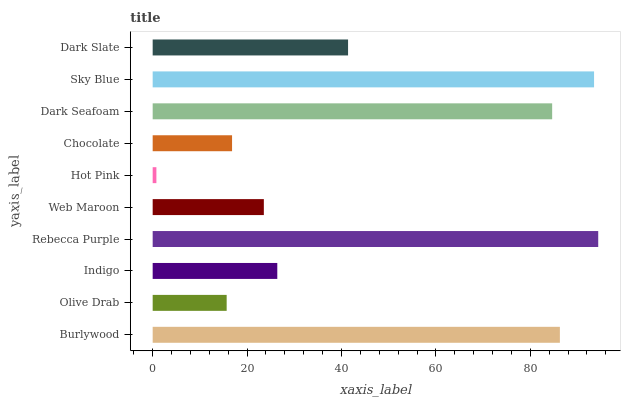Is Hot Pink the minimum?
Answer yes or no. Yes. Is Rebecca Purple the maximum?
Answer yes or no. Yes. Is Olive Drab the minimum?
Answer yes or no. No. Is Olive Drab the maximum?
Answer yes or no. No. Is Burlywood greater than Olive Drab?
Answer yes or no. Yes. Is Olive Drab less than Burlywood?
Answer yes or no. Yes. Is Olive Drab greater than Burlywood?
Answer yes or no. No. Is Burlywood less than Olive Drab?
Answer yes or no. No. Is Dark Slate the high median?
Answer yes or no. Yes. Is Indigo the low median?
Answer yes or no. Yes. Is Burlywood the high median?
Answer yes or no. No. Is Olive Drab the low median?
Answer yes or no. No. 